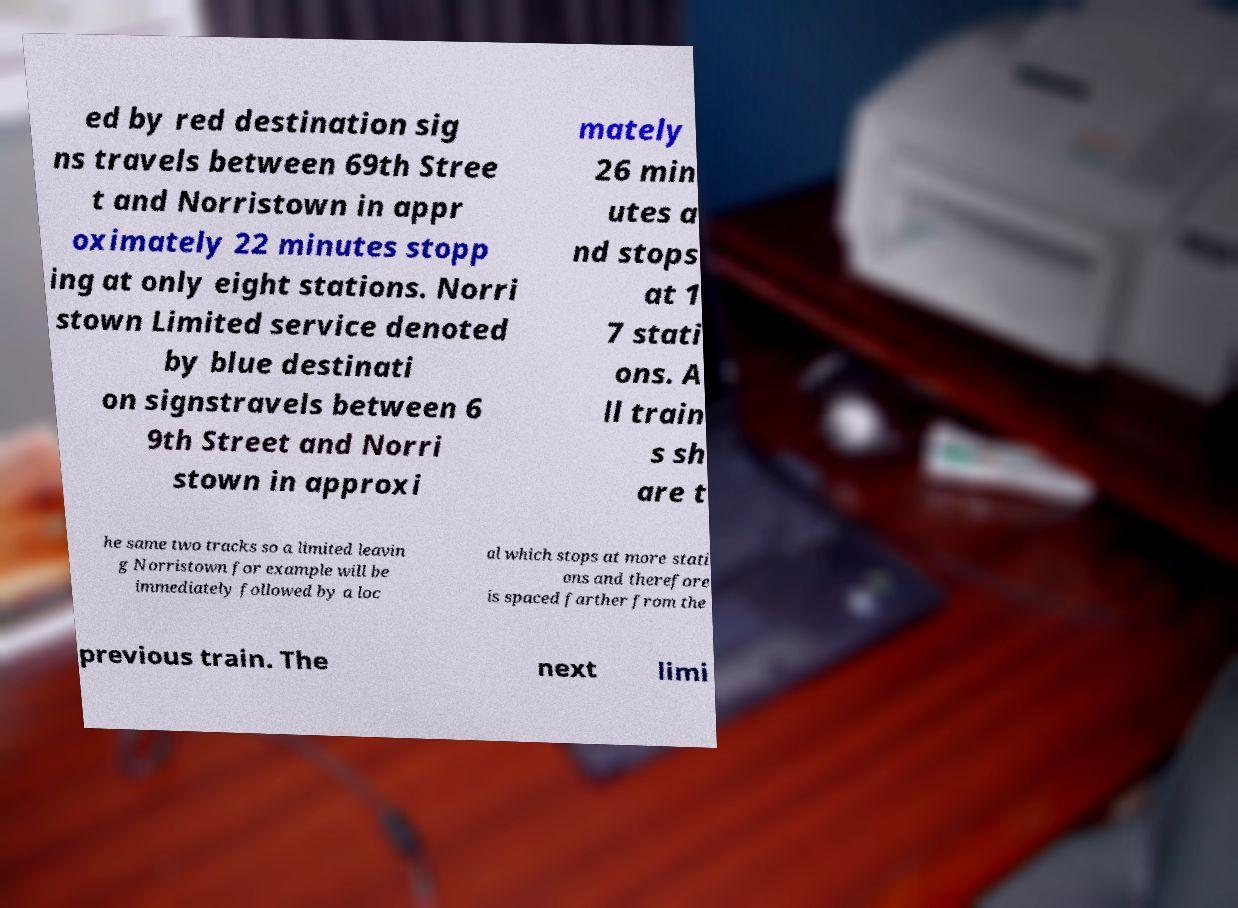There's text embedded in this image that I need extracted. Can you transcribe it verbatim? ed by red destination sig ns travels between 69th Stree t and Norristown in appr oximately 22 minutes stopp ing at only eight stations. Norri stown Limited service denoted by blue destinati on signstravels between 6 9th Street and Norri stown in approxi mately 26 min utes a nd stops at 1 7 stati ons. A ll train s sh are t he same two tracks so a limited leavin g Norristown for example will be immediately followed by a loc al which stops at more stati ons and therefore is spaced farther from the previous train. The next limi 